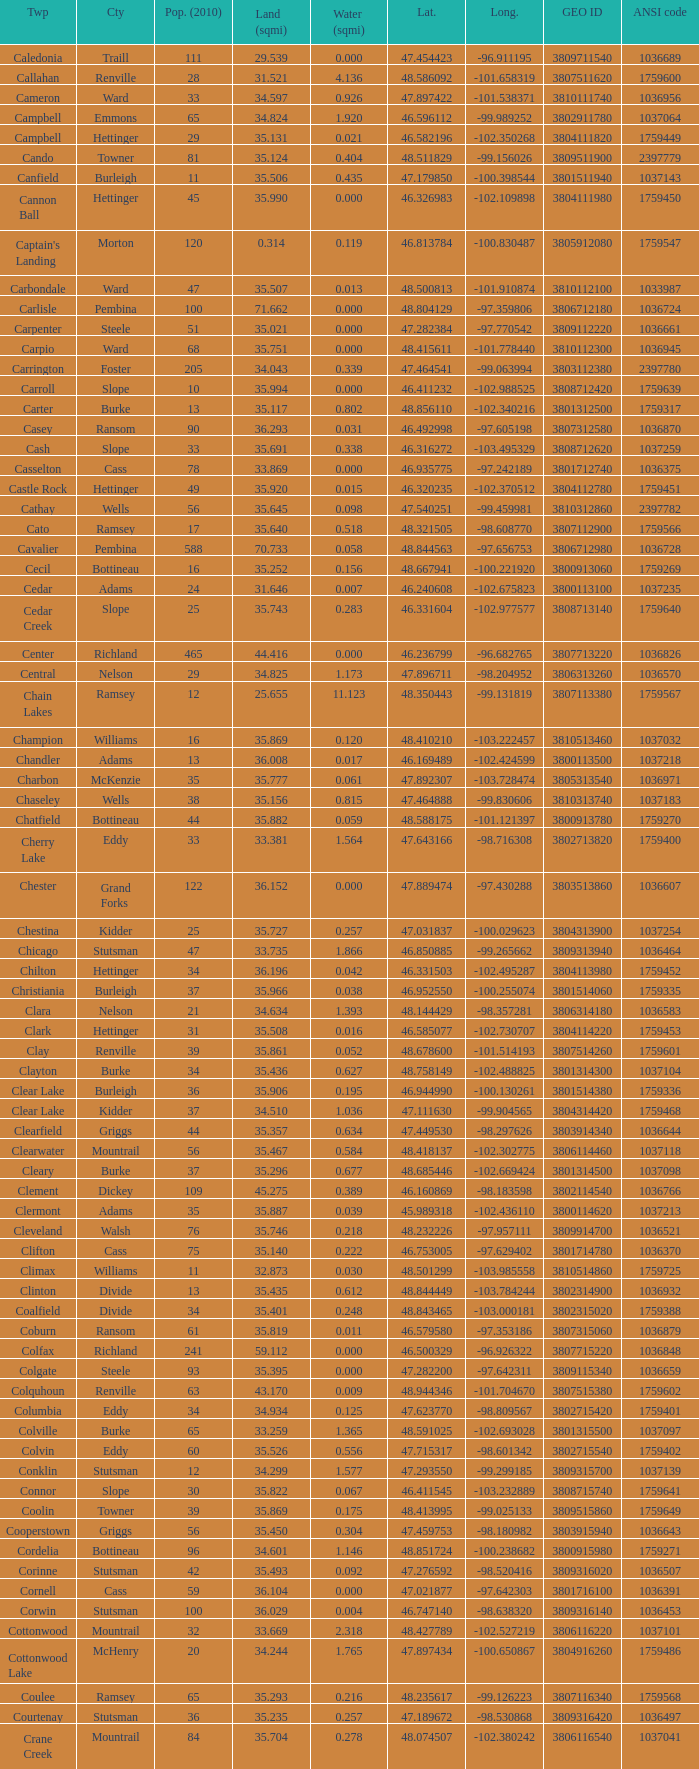What was the county with a longitude of -102.302775? Mountrail. 